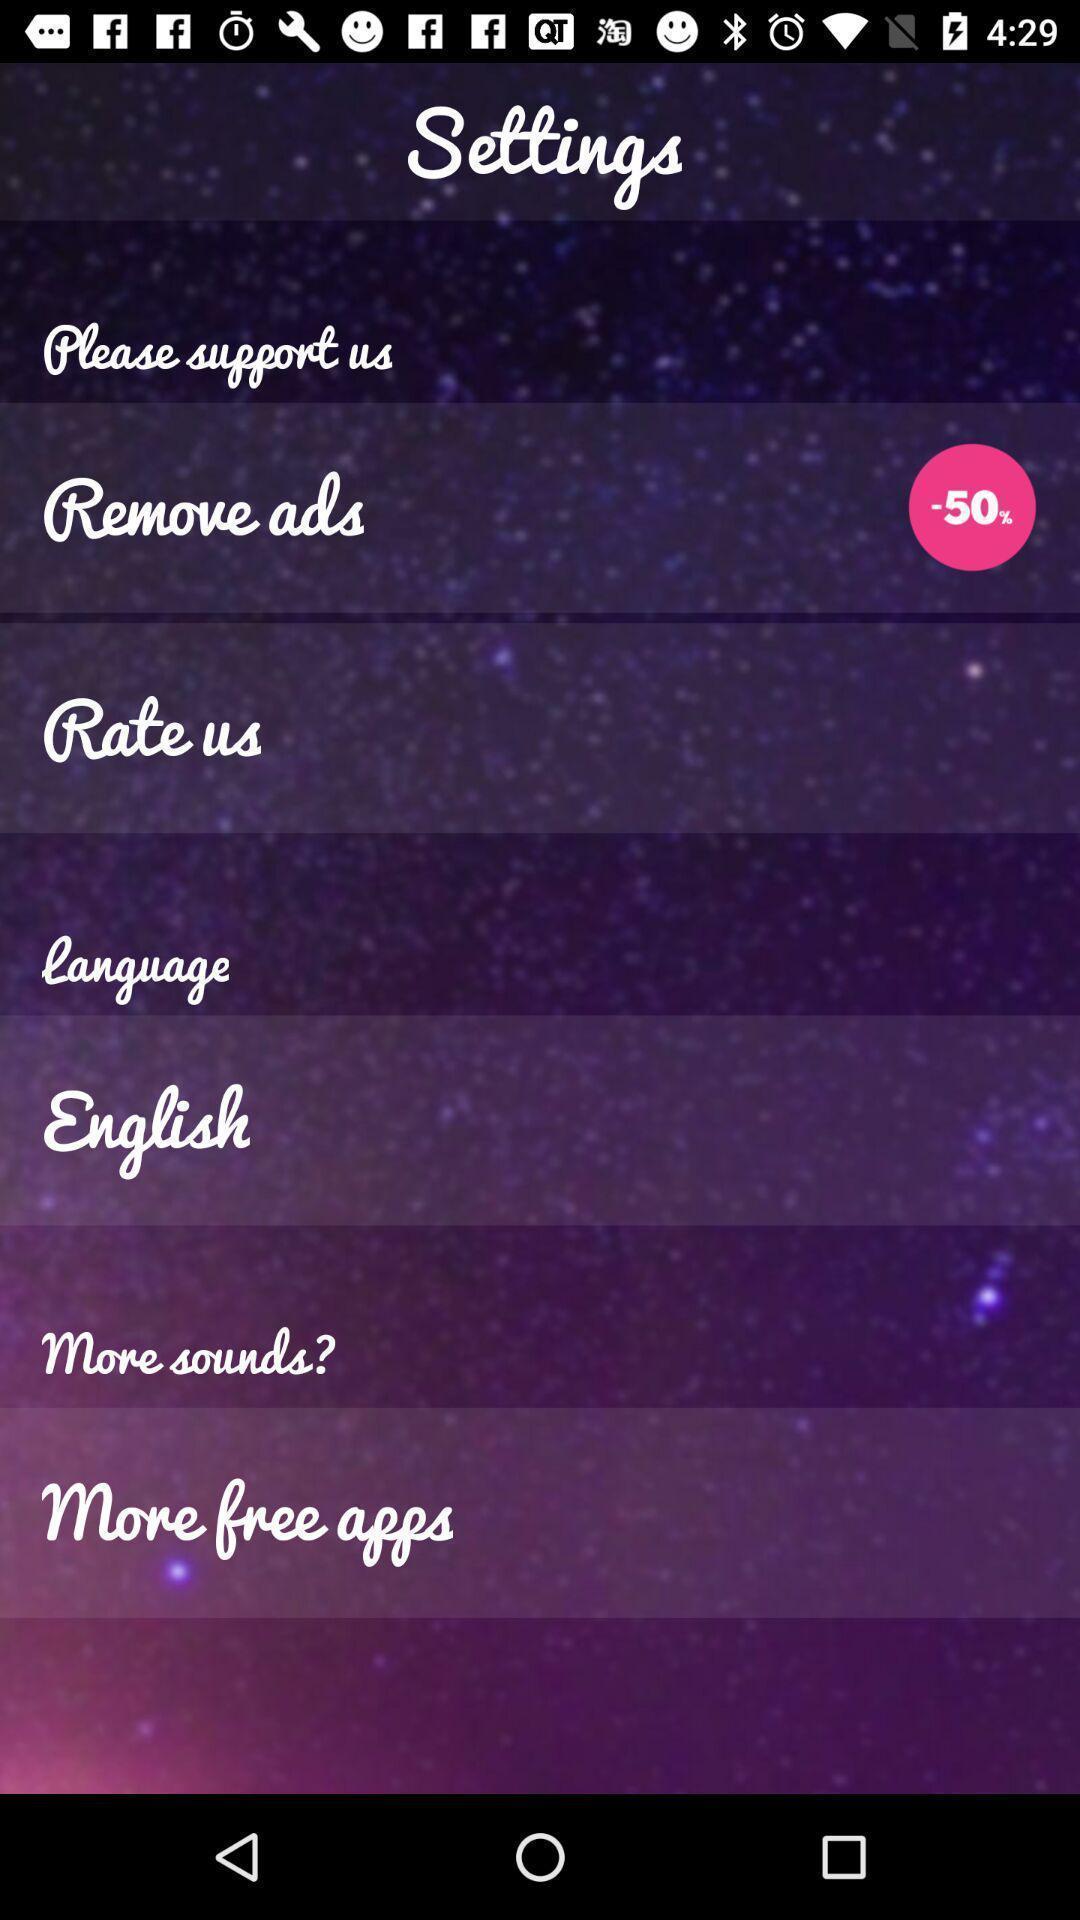What is the overall content of this screenshot? Page displaying the various options. 